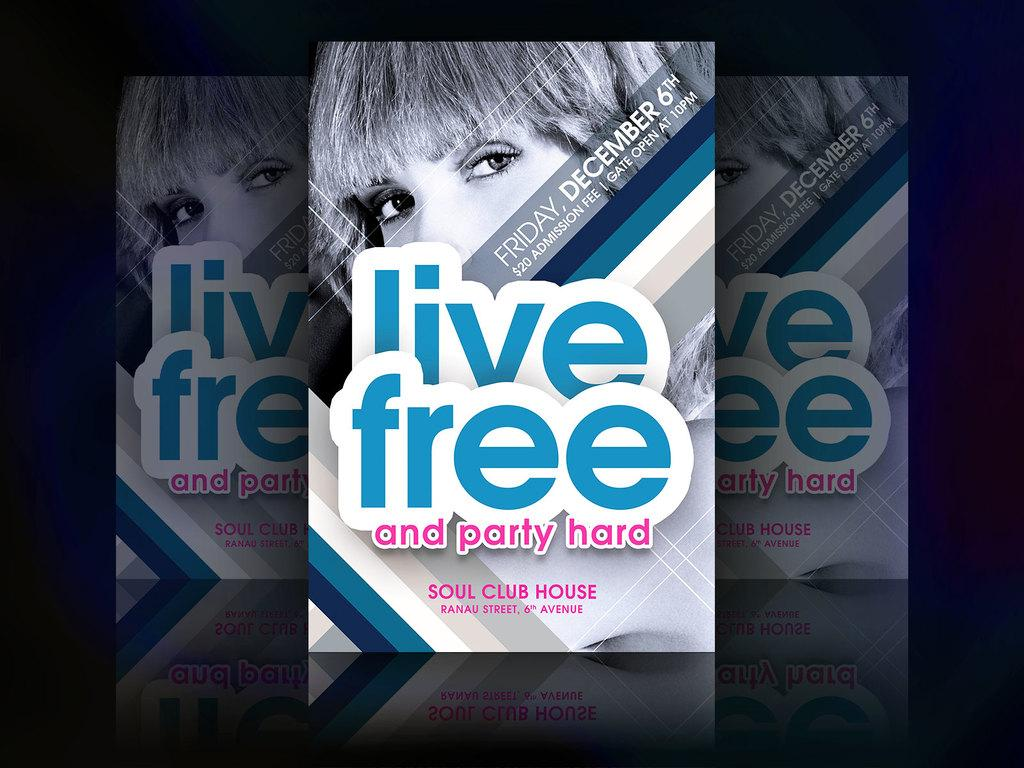<image>
Create a compact narrative representing the image presented. An advertisement for a large party with the words "Live Free and party hard." printed on the front. 